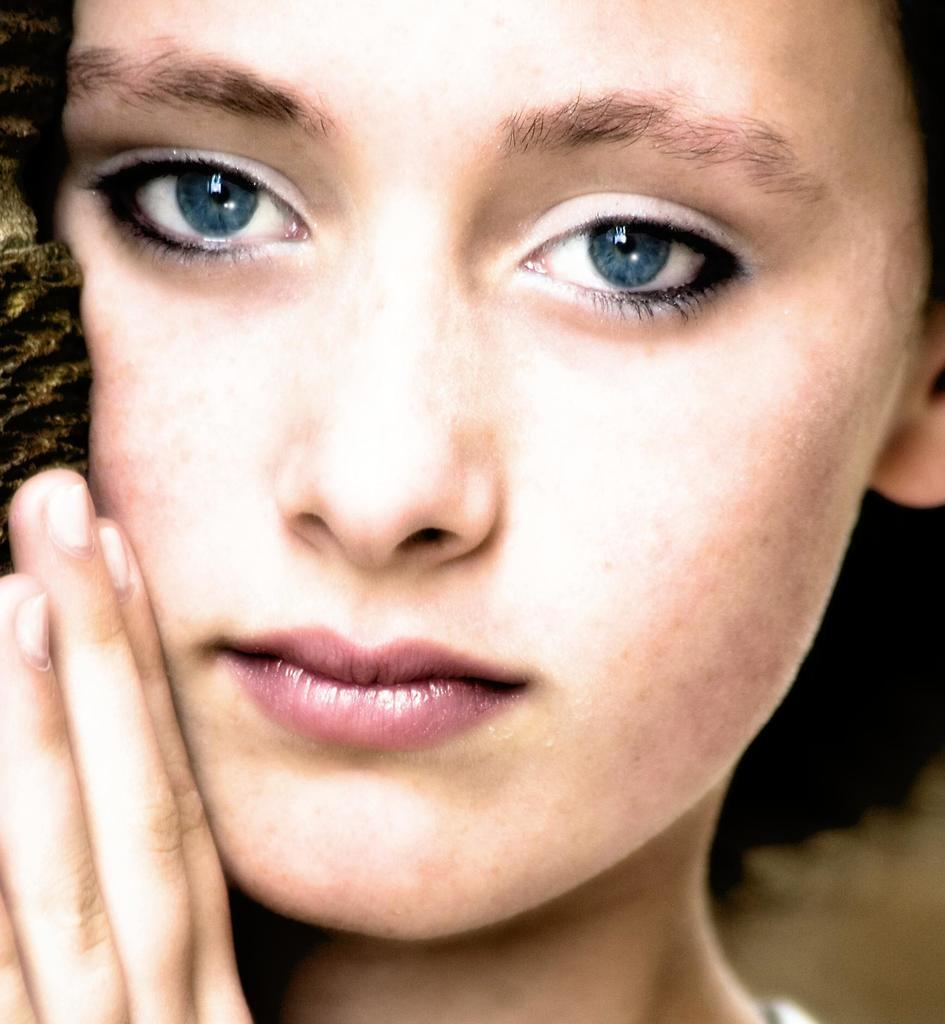What is the main subject of the image? The main subject of the image is a woman. What is the woman doing in the image? The woman is touching an object in her hand. What type of ticket does the woman have in her hand in the image? There is no ticket present in the image; the woman is simply touching an object in her hand. What country is the woman from in the image? The country of origin of the woman cannot be determined from the image alone. 